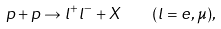<formula> <loc_0><loc_0><loc_500><loc_500>p + p \to l ^ { + } l ^ { - } + X \quad ( l = e , \mu ) ,</formula> 